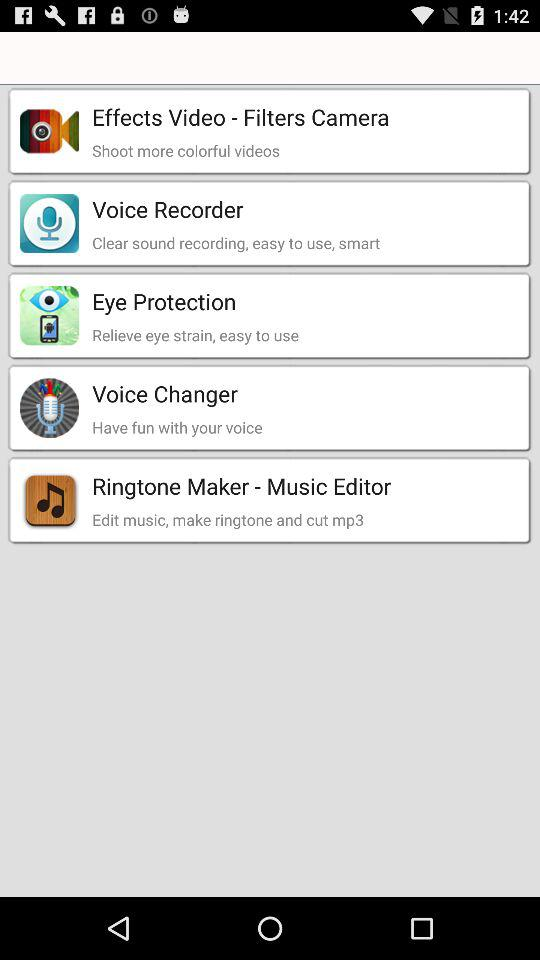Which music editor app can we use to edit music, make ringtones and cut mp3? You can use the "Ringtone Maker - Music Editor" app to edit music, make ringtones and cut mp3. 